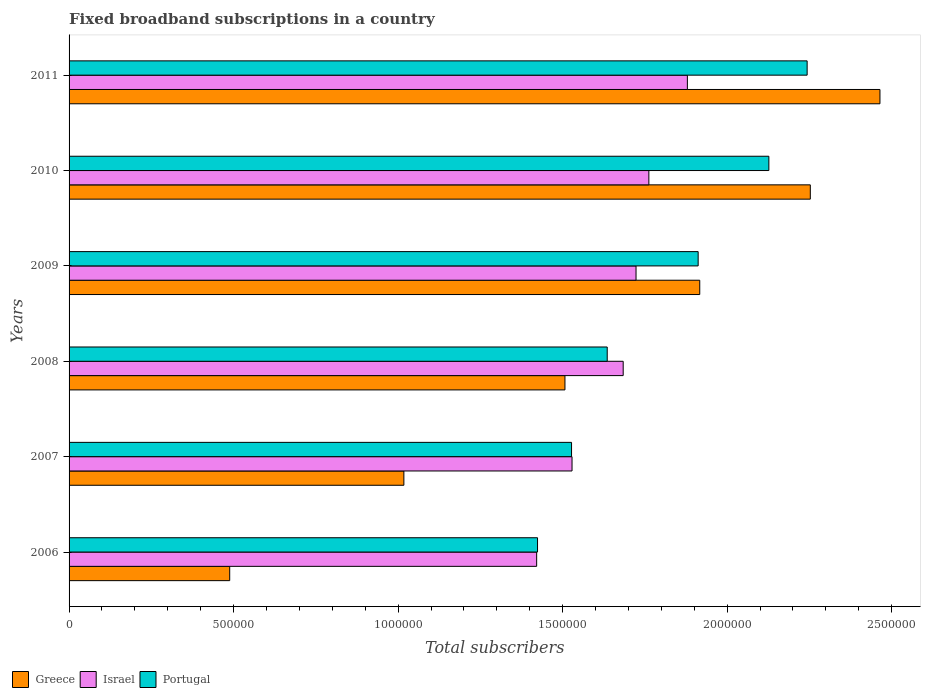How many different coloured bars are there?
Offer a terse response. 3. How many groups of bars are there?
Give a very brief answer. 6. In how many cases, is the number of bars for a given year not equal to the number of legend labels?
Make the answer very short. 0. What is the number of broadband subscriptions in Portugal in 2008?
Provide a short and direct response. 1.64e+06. Across all years, what is the maximum number of broadband subscriptions in Portugal?
Give a very brief answer. 2.24e+06. Across all years, what is the minimum number of broadband subscriptions in Portugal?
Give a very brief answer. 1.42e+06. In which year was the number of broadband subscriptions in Israel maximum?
Your answer should be compact. 2011. In which year was the number of broadband subscriptions in Portugal minimum?
Make the answer very short. 2006. What is the total number of broadband subscriptions in Portugal in the graph?
Make the answer very short. 1.09e+07. What is the difference between the number of broadband subscriptions in Greece in 2008 and that in 2011?
Ensure brevity in your answer.  -9.57e+05. What is the difference between the number of broadband subscriptions in Israel in 2010 and the number of broadband subscriptions in Portugal in 2009?
Give a very brief answer. -1.50e+05. What is the average number of broadband subscriptions in Portugal per year?
Your answer should be very brief. 1.81e+06. In the year 2009, what is the difference between the number of broadband subscriptions in Portugal and number of broadband subscriptions in Israel?
Offer a very short reply. 1.89e+05. In how many years, is the number of broadband subscriptions in Israel greater than 1800000 ?
Offer a very short reply. 1. What is the ratio of the number of broadband subscriptions in Israel in 2010 to that in 2011?
Your answer should be very brief. 0.94. Is the difference between the number of broadband subscriptions in Portugal in 2008 and 2009 greater than the difference between the number of broadband subscriptions in Israel in 2008 and 2009?
Keep it short and to the point. No. What is the difference between the highest and the second highest number of broadband subscriptions in Greece?
Your answer should be compact. 2.12e+05. What is the difference between the highest and the lowest number of broadband subscriptions in Portugal?
Give a very brief answer. 8.19e+05. In how many years, is the number of broadband subscriptions in Greece greater than the average number of broadband subscriptions in Greece taken over all years?
Offer a very short reply. 3. Are all the bars in the graph horizontal?
Your answer should be compact. Yes. What is the difference between two consecutive major ticks on the X-axis?
Your answer should be compact. 5.00e+05. Does the graph contain grids?
Your answer should be compact. No. Where does the legend appear in the graph?
Your response must be concise. Bottom left. How are the legend labels stacked?
Offer a terse response. Horizontal. What is the title of the graph?
Your answer should be very brief. Fixed broadband subscriptions in a country. Does "Costa Rica" appear as one of the legend labels in the graph?
Offer a terse response. No. What is the label or title of the X-axis?
Provide a short and direct response. Total subscribers. What is the Total subscribers of Greece in 2006?
Make the answer very short. 4.88e+05. What is the Total subscribers of Israel in 2006?
Ensure brevity in your answer.  1.42e+06. What is the Total subscribers in Portugal in 2006?
Give a very brief answer. 1.42e+06. What is the Total subscribers of Greece in 2007?
Provide a succinct answer. 1.02e+06. What is the Total subscribers in Israel in 2007?
Offer a terse response. 1.53e+06. What is the Total subscribers in Portugal in 2007?
Your answer should be compact. 1.53e+06. What is the Total subscribers of Greece in 2008?
Provide a short and direct response. 1.51e+06. What is the Total subscribers of Israel in 2008?
Provide a succinct answer. 1.68e+06. What is the Total subscribers in Portugal in 2008?
Your response must be concise. 1.64e+06. What is the Total subscribers in Greece in 2009?
Ensure brevity in your answer.  1.92e+06. What is the Total subscribers in Israel in 2009?
Provide a short and direct response. 1.72e+06. What is the Total subscribers in Portugal in 2009?
Offer a very short reply. 1.91e+06. What is the Total subscribers in Greece in 2010?
Provide a short and direct response. 2.25e+06. What is the Total subscribers in Israel in 2010?
Make the answer very short. 1.76e+06. What is the Total subscribers in Portugal in 2010?
Offer a very short reply. 2.13e+06. What is the Total subscribers of Greece in 2011?
Provide a short and direct response. 2.46e+06. What is the Total subscribers in Israel in 2011?
Make the answer very short. 1.88e+06. What is the Total subscribers in Portugal in 2011?
Offer a terse response. 2.24e+06. Across all years, what is the maximum Total subscribers in Greece?
Keep it short and to the point. 2.46e+06. Across all years, what is the maximum Total subscribers of Israel?
Make the answer very short. 1.88e+06. Across all years, what is the maximum Total subscribers in Portugal?
Offer a terse response. 2.24e+06. Across all years, what is the minimum Total subscribers of Greece?
Offer a terse response. 4.88e+05. Across all years, what is the minimum Total subscribers in Israel?
Offer a very short reply. 1.42e+06. Across all years, what is the minimum Total subscribers of Portugal?
Offer a terse response. 1.42e+06. What is the total Total subscribers in Greece in the graph?
Your answer should be very brief. 9.65e+06. What is the total Total subscribers of Israel in the graph?
Provide a succinct answer. 1.00e+07. What is the total Total subscribers of Portugal in the graph?
Your response must be concise. 1.09e+07. What is the difference between the Total subscribers in Greece in 2006 and that in 2007?
Keep it short and to the point. -5.29e+05. What is the difference between the Total subscribers in Israel in 2006 and that in 2007?
Offer a terse response. -1.08e+05. What is the difference between the Total subscribers of Portugal in 2006 and that in 2007?
Provide a succinct answer. -1.03e+05. What is the difference between the Total subscribers in Greece in 2006 and that in 2008?
Your answer should be very brief. -1.02e+06. What is the difference between the Total subscribers in Israel in 2006 and that in 2008?
Offer a terse response. -2.63e+05. What is the difference between the Total subscribers of Portugal in 2006 and that in 2008?
Offer a terse response. -2.12e+05. What is the difference between the Total subscribers in Greece in 2006 and that in 2009?
Keep it short and to the point. -1.43e+06. What is the difference between the Total subscribers of Israel in 2006 and that in 2009?
Make the answer very short. -3.02e+05. What is the difference between the Total subscribers of Portugal in 2006 and that in 2009?
Make the answer very short. -4.88e+05. What is the difference between the Total subscribers of Greece in 2006 and that in 2010?
Your response must be concise. -1.76e+06. What is the difference between the Total subscribers in Israel in 2006 and that in 2010?
Give a very brief answer. -3.41e+05. What is the difference between the Total subscribers of Portugal in 2006 and that in 2010?
Keep it short and to the point. -7.03e+05. What is the difference between the Total subscribers in Greece in 2006 and that in 2011?
Your response must be concise. -1.98e+06. What is the difference between the Total subscribers of Israel in 2006 and that in 2011?
Offer a very short reply. -4.58e+05. What is the difference between the Total subscribers of Portugal in 2006 and that in 2011?
Provide a succinct answer. -8.19e+05. What is the difference between the Total subscribers in Greece in 2007 and that in 2008?
Offer a very short reply. -4.90e+05. What is the difference between the Total subscribers in Israel in 2007 and that in 2008?
Your response must be concise. -1.56e+05. What is the difference between the Total subscribers of Portugal in 2007 and that in 2008?
Your response must be concise. -1.08e+05. What is the difference between the Total subscribers of Greece in 2007 and that in 2009?
Your response must be concise. -8.99e+05. What is the difference between the Total subscribers in Israel in 2007 and that in 2009?
Offer a terse response. -1.94e+05. What is the difference between the Total subscribers of Portugal in 2007 and that in 2009?
Make the answer very short. -3.85e+05. What is the difference between the Total subscribers in Greece in 2007 and that in 2010?
Your answer should be compact. -1.24e+06. What is the difference between the Total subscribers of Israel in 2007 and that in 2010?
Ensure brevity in your answer.  -2.34e+05. What is the difference between the Total subscribers in Portugal in 2007 and that in 2010?
Provide a short and direct response. -6.00e+05. What is the difference between the Total subscribers of Greece in 2007 and that in 2011?
Offer a very short reply. -1.45e+06. What is the difference between the Total subscribers of Israel in 2007 and that in 2011?
Your answer should be compact. -3.51e+05. What is the difference between the Total subscribers in Portugal in 2007 and that in 2011?
Provide a succinct answer. -7.16e+05. What is the difference between the Total subscribers of Greece in 2008 and that in 2009?
Your response must be concise. -4.10e+05. What is the difference between the Total subscribers in Israel in 2008 and that in 2009?
Make the answer very short. -3.90e+04. What is the difference between the Total subscribers of Portugal in 2008 and that in 2009?
Offer a very short reply. -2.76e+05. What is the difference between the Total subscribers of Greece in 2008 and that in 2010?
Provide a short and direct response. -7.46e+05. What is the difference between the Total subscribers in Israel in 2008 and that in 2010?
Provide a short and direct response. -7.80e+04. What is the difference between the Total subscribers in Portugal in 2008 and that in 2010?
Make the answer very short. -4.91e+05. What is the difference between the Total subscribers of Greece in 2008 and that in 2011?
Your answer should be very brief. -9.57e+05. What is the difference between the Total subscribers of Israel in 2008 and that in 2011?
Offer a very short reply. -1.95e+05. What is the difference between the Total subscribers of Portugal in 2008 and that in 2011?
Offer a terse response. -6.08e+05. What is the difference between the Total subscribers in Greece in 2009 and that in 2010?
Offer a terse response. -3.36e+05. What is the difference between the Total subscribers in Israel in 2009 and that in 2010?
Provide a short and direct response. -3.90e+04. What is the difference between the Total subscribers of Portugal in 2009 and that in 2010?
Your answer should be very brief. -2.15e+05. What is the difference between the Total subscribers of Greece in 2009 and that in 2011?
Offer a very short reply. -5.48e+05. What is the difference between the Total subscribers in Israel in 2009 and that in 2011?
Provide a short and direct response. -1.56e+05. What is the difference between the Total subscribers of Portugal in 2009 and that in 2011?
Ensure brevity in your answer.  -3.31e+05. What is the difference between the Total subscribers in Greece in 2010 and that in 2011?
Offer a terse response. -2.12e+05. What is the difference between the Total subscribers in Israel in 2010 and that in 2011?
Your answer should be very brief. -1.17e+05. What is the difference between the Total subscribers in Portugal in 2010 and that in 2011?
Keep it short and to the point. -1.16e+05. What is the difference between the Total subscribers of Greece in 2006 and the Total subscribers of Israel in 2007?
Your response must be concise. -1.04e+06. What is the difference between the Total subscribers of Greece in 2006 and the Total subscribers of Portugal in 2007?
Offer a very short reply. -1.04e+06. What is the difference between the Total subscribers in Israel in 2006 and the Total subscribers in Portugal in 2007?
Give a very brief answer. -1.06e+05. What is the difference between the Total subscribers in Greece in 2006 and the Total subscribers in Israel in 2008?
Your answer should be compact. -1.20e+06. What is the difference between the Total subscribers of Greece in 2006 and the Total subscribers of Portugal in 2008?
Provide a succinct answer. -1.15e+06. What is the difference between the Total subscribers in Israel in 2006 and the Total subscribers in Portugal in 2008?
Make the answer very short. -2.14e+05. What is the difference between the Total subscribers in Greece in 2006 and the Total subscribers in Israel in 2009?
Offer a terse response. -1.23e+06. What is the difference between the Total subscribers in Greece in 2006 and the Total subscribers in Portugal in 2009?
Make the answer very short. -1.42e+06. What is the difference between the Total subscribers of Israel in 2006 and the Total subscribers of Portugal in 2009?
Ensure brevity in your answer.  -4.91e+05. What is the difference between the Total subscribers in Greece in 2006 and the Total subscribers in Israel in 2010?
Offer a very short reply. -1.27e+06. What is the difference between the Total subscribers of Greece in 2006 and the Total subscribers of Portugal in 2010?
Provide a short and direct response. -1.64e+06. What is the difference between the Total subscribers of Israel in 2006 and the Total subscribers of Portugal in 2010?
Offer a terse response. -7.06e+05. What is the difference between the Total subscribers of Greece in 2006 and the Total subscribers of Israel in 2011?
Make the answer very short. -1.39e+06. What is the difference between the Total subscribers in Greece in 2006 and the Total subscribers in Portugal in 2011?
Keep it short and to the point. -1.75e+06. What is the difference between the Total subscribers of Israel in 2006 and the Total subscribers of Portugal in 2011?
Your response must be concise. -8.22e+05. What is the difference between the Total subscribers in Greece in 2007 and the Total subscribers in Israel in 2008?
Ensure brevity in your answer.  -6.67e+05. What is the difference between the Total subscribers of Greece in 2007 and the Total subscribers of Portugal in 2008?
Ensure brevity in your answer.  -6.18e+05. What is the difference between the Total subscribers in Israel in 2007 and the Total subscribers in Portugal in 2008?
Offer a very short reply. -1.07e+05. What is the difference between the Total subscribers of Greece in 2007 and the Total subscribers of Israel in 2009?
Ensure brevity in your answer.  -7.06e+05. What is the difference between the Total subscribers in Greece in 2007 and the Total subscribers in Portugal in 2009?
Ensure brevity in your answer.  -8.94e+05. What is the difference between the Total subscribers in Israel in 2007 and the Total subscribers in Portugal in 2009?
Ensure brevity in your answer.  -3.83e+05. What is the difference between the Total subscribers in Greece in 2007 and the Total subscribers in Israel in 2010?
Your answer should be compact. -7.45e+05. What is the difference between the Total subscribers in Greece in 2007 and the Total subscribers in Portugal in 2010?
Offer a terse response. -1.11e+06. What is the difference between the Total subscribers of Israel in 2007 and the Total subscribers of Portugal in 2010?
Offer a very short reply. -5.98e+05. What is the difference between the Total subscribers in Greece in 2007 and the Total subscribers in Israel in 2011?
Your answer should be very brief. -8.62e+05. What is the difference between the Total subscribers in Greece in 2007 and the Total subscribers in Portugal in 2011?
Give a very brief answer. -1.23e+06. What is the difference between the Total subscribers of Israel in 2007 and the Total subscribers of Portugal in 2011?
Offer a terse response. -7.15e+05. What is the difference between the Total subscribers of Greece in 2008 and the Total subscribers of Israel in 2009?
Your answer should be very brief. -2.16e+05. What is the difference between the Total subscribers of Greece in 2008 and the Total subscribers of Portugal in 2009?
Offer a very short reply. -4.05e+05. What is the difference between the Total subscribers in Israel in 2008 and the Total subscribers in Portugal in 2009?
Give a very brief answer. -2.28e+05. What is the difference between the Total subscribers in Greece in 2008 and the Total subscribers in Israel in 2010?
Offer a very short reply. -2.55e+05. What is the difference between the Total subscribers of Greece in 2008 and the Total subscribers of Portugal in 2010?
Make the answer very short. -6.20e+05. What is the difference between the Total subscribers of Israel in 2008 and the Total subscribers of Portugal in 2010?
Make the answer very short. -4.43e+05. What is the difference between the Total subscribers in Greece in 2008 and the Total subscribers in Israel in 2011?
Provide a succinct answer. -3.72e+05. What is the difference between the Total subscribers in Greece in 2008 and the Total subscribers in Portugal in 2011?
Give a very brief answer. -7.36e+05. What is the difference between the Total subscribers of Israel in 2008 and the Total subscribers of Portugal in 2011?
Your answer should be very brief. -5.59e+05. What is the difference between the Total subscribers in Greece in 2009 and the Total subscribers in Israel in 2010?
Your answer should be very brief. 1.55e+05. What is the difference between the Total subscribers of Greece in 2009 and the Total subscribers of Portugal in 2010?
Keep it short and to the point. -2.10e+05. What is the difference between the Total subscribers in Israel in 2009 and the Total subscribers in Portugal in 2010?
Your answer should be very brief. -4.04e+05. What is the difference between the Total subscribers of Greece in 2009 and the Total subscribers of Israel in 2011?
Offer a terse response. 3.76e+04. What is the difference between the Total subscribers of Greece in 2009 and the Total subscribers of Portugal in 2011?
Offer a very short reply. -3.26e+05. What is the difference between the Total subscribers of Israel in 2009 and the Total subscribers of Portugal in 2011?
Your answer should be very brief. -5.20e+05. What is the difference between the Total subscribers in Greece in 2010 and the Total subscribers in Israel in 2011?
Offer a very short reply. 3.74e+05. What is the difference between the Total subscribers of Greece in 2010 and the Total subscribers of Portugal in 2011?
Your answer should be very brief. 9617. What is the difference between the Total subscribers in Israel in 2010 and the Total subscribers in Portugal in 2011?
Give a very brief answer. -4.81e+05. What is the average Total subscribers in Greece per year?
Provide a succinct answer. 1.61e+06. What is the average Total subscribers in Israel per year?
Offer a very short reply. 1.67e+06. What is the average Total subscribers in Portugal per year?
Your response must be concise. 1.81e+06. In the year 2006, what is the difference between the Total subscribers of Greece and Total subscribers of Israel?
Ensure brevity in your answer.  -9.33e+05. In the year 2006, what is the difference between the Total subscribers of Greece and Total subscribers of Portugal?
Your answer should be compact. -9.36e+05. In the year 2006, what is the difference between the Total subscribers of Israel and Total subscribers of Portugal?
Your answer should be compact. -2687. In the year 2007, what is the difference between the Total subscribers of Greece and Total subscribers of Israel?
Keep it short and to the point. -5.11e+05. In the year 2007, what is the difference between the Total subscribers of Greece and Total subscribers of Portugal?
Keep it short and to the point. -5.10e+05. In the year 2007, what is the difference between the Total subscribers in Israel and Total subscribers in Portugal?
Offer a very short reply. 1450. In the year 2008, what is the difference between the Total subscribers of Greece and Total subscribers of Israel?
Offer a terse response. -1.77e+05. In the year 2008, what is the difference between the Total subscribers of Greece and Total subscribers of Portugal?
Make the answer very short. -1.28e+05. In the year 2008, what is the difference between the Total subscribers of Israel and Total subscribers of Portugal?
Your answer should be compact. 4.86e+04. In the year 2009, what is the difference between the Total subscribers of Greece and Total subscribers of Israel?
Make the answer very short. 1.94e+05. In the year 2009, what is the difference between the Total subscribers in Greece and Total subscribers in Portugal?
Your response must be concise. 4803. In the year 2009, what is the difference between the Total subscribers in Israel and Total subscribers in Portugal?
Offer a terse response. -1.89e+05. In the year 2010, what is the difference between the Total subscribers of Greece and Total subscribers of Israel?
Provide a succinct answer. 4.91e+05. In the year 2010, what is the difference between the Total subscribers of Greece and Total subscribers of Portugal?
Provide a succinct answer. 1.26e+05. In the year 2010, what is the difference between the Total subscribers in Israel and Total subscribers in Portugal?
Your response must be concise. -3.65e+05. In the year 2011, what is the difference between the Total subscribers of Greece and Total subscribers of Israel?
Provide a short and direct response. 5.85e+05. In the year 2011, what is the difference between the Total subscribers in Greece and Total subscribers in Portugal?
Keep it short and to the point. 2.21e+05. In the year 2011, what is the difference between the Total subscribers of Israel and Total subscribers of Portugal?
Offer a very short reply. -3.64e+05. What is the ratio of the Total subscribers in Greece in 2006 to that in 2007?
Provide a succinct answer. 0.48. What is the ratio of the Total subscribers of Israel in 2006 to that in 2007?
Provide a succinct answer. 0.93. What is the ratio of the Total subscribers of Portugal in 2006 to that in 2007?
Provide a short and direct response. 0.93. What is the ratio of the Total subscribers in Greece in 2006 to that in 2008?
Provide a short and direct response. 0.32. What is the ratio of the Total subscribers in Israel in 2006 to that in 2008?
Offer a terse response. 0.84. What is the ratio of the Total subscribers of Portugal in 2006 to that in 2008?
Your answer should be compact. 0.87. What is the ratio of the Total subscribers in Greece in 2006 to that in 2009?
Make the answer very short. 0.25. What is the ratio of the Total subscribers in Israel in 2006 to that in 2009?
Keep it short and to the point. 0.82. What is the ratio of the Total subscribers of Portugal in 2006 to that in 2009?
Your response must be concise. 0.74. What is the ratio of the Total subscribers in Greece in 2006 to that in 2010?
Ensure brevity in your answer.  0.22. What is the ratio of the Total subscribers in Israel in 2006 to that in 2010?
Provide a succinct answer. 0.81. What is the ratio of the Total subscribers of Portugal in 2006 to that in 2010?
Provide a short and direct response. 0.67. What is the ratio of the Total subscribers of Greece in 2006 to that in 2011?
Give a very brief answer. 0.2. What is the ratio of the Total subscribers of Israel in 2006 to that in 2011?
Provide a short and direct response. 0.76. What is the ratio of the Total subscribers in Portugal in 2006 to that in 2011?
Provide a short and direct response. 0.63. What is the ratio of the Total subscribers in Greece in 2007 to that in 2008?
Make the answer very short. 0.68. What is the ratio of the Total subscribers in Israel in 2007 to that in 2008?
Your answer should be very brief. 0.91. What is the ratio of the Total subscribers of Portugal in 2007 to that in 2008?
Your answer should be compact. 0.93. What is the ratio of the Total subscribers in Greece in 2007 to that in 2009?
Provide a succinct answer. 0.53. What is the ratio of the Total subscribers of Israel in 2007 to that in 2009?
Provide a succinct answer. 0.89. What is the ratio of the Total subscribers of Portugal in 2007 to that in 2009?
Offer a terse response. 0.8. What is the ratio of the Total subscribers of Greece in 2007 to that in 2010?
Your response must be concise. 0.45. What is the ratio of the Total subscribers in Israel in 2007 to that in 2010?
Make the answer very short. 0.87. What is the ratio of the Total subscribers of Portugal in 2007 to that in 2010?
Provide a succinct answer. 0.72. What is the ratio of the Total subscribers of Greece in 2007 to that in 2011?
Provide a short and direct response. 0.41. What is the ratio of the Total subscribers of Israel in 2007 to that in 2011?
Provide a succinct answer. 0.81. What is the ratio of the Total subscribers in Portugal in 2007 to that in 2011?
Offer a very short reply. 0.68. What is the ratio of the Total subscribers of Greece in 2008 to that in 2009?
Offer a very short reply. 0.79. What is the ratio of the Total subscribers in Israel in 2008 to that in 2009?
Offer a terse response. 0.98. What is the ratio of the Total subscribers in Portugal in 2008 to that in 2009?
Your answer should be very brief. 0.86. What is the ratio of the Total subscribers of Greece in 2008 to that in 2010?
Make the answer very short. 0.67. What is the ratio of the Total subscribers of Israel in 2008 to that in 2010?
Offer a terse response. 0.96. What is the ratio of the Total subscribers of Portugal in 2008 to that in 2010?
Give a very brief answer. 0.77. What is the ratio of the Total subscribers of Greece in 2008 to that in 2011?
Give a very brief answer. 0.61. What is the ratio of the Total subscribers of Israel in 2008 to that in 2011?
Your answer should be compact. 0.9. What is the ratio of the Total subscribers of Portugal in 2008 to that in 2011?
Provide a short and direct response. 0.73. What is the ratio of the Total subscribers in Greece in 2009 to that in 2010?
Provide a short and direct response. 0.85. What is the ratio of the Total subscribers of Israel in 2009 to that in 2010?
Offer a very short reply. 0.98. What is the ratio of the Total subscribers in Portugal in 2009 to that in 2010?
Your answer should be very brief. 0.9. What is the ratio of the Total subscribers in Greece in 2009 to that in 2011?
Provide a succinct answer. 0.78. What is the ratio of the Total subscribers in Israel in 2009 to that in 2011?
Ensure brevity in your answer.  0.92. What is the ratio of the Total subscribers of Portugal in 2009 to that in 2011?
Ensure brevity in your answer.  0.85. What is the ratio of the Total subscribers of Greece in 2010 to that in 2011?
Ensure brevity in your answer.  0.91. What is the ratio of the Total subscribers of Israel in 2010 to that in 2011?
Offer a very short reply. 0.94. What is the ratio of the Total subscribers of Portugal in 2010 to that in 2011?
Your answer should be very brief. 0.95. What is the difference between the highest and the second highest Total subscribers in Greece?
Give a very brief answer. 2.12e+05. What is the difference between the highest and the second highest Total subscribers of Israel?
Offer a very short reply. 1.17e+05. What is the difference between the highest and the second highest Total subscribers in Portugal?
Provide a succinct answer. 1.16e+05. What is the difference between the highest and the lowest Total subscribers of Greece?
Keep it short and to the point. 1.98e+06. What is the difference between the highest and the lowest Total subscribers of Israel?
Your answer should be compact. 4.58e+05. What is the difference between the highest and the lowest Total subscribers of Portugal?
Make the answer very short. 8.19e+05. 